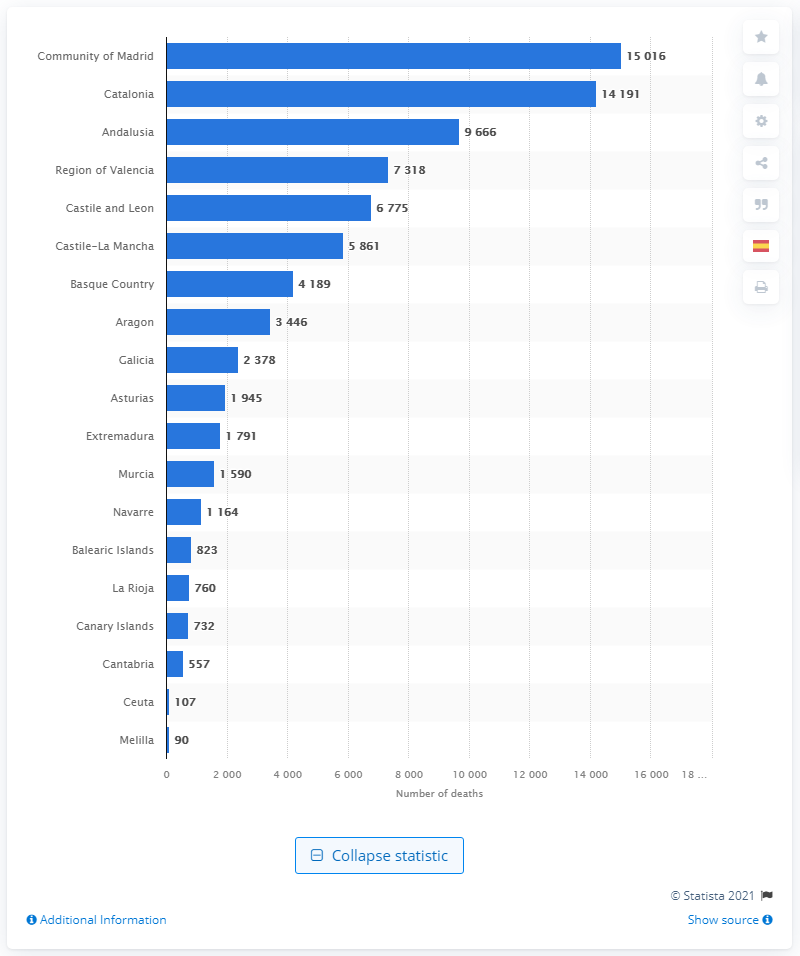How many deaths have been confirmed as a result of complications from coronavirus? The image displays a bar chart with the number of deaths attributed to complications from coronavirus in various regions. The highest number is seen in the Community of Madrid with over 15,000 deaths. To provide an exact figure for the total, one would need to sum the number of deaths from all regions as presented in the chart. 